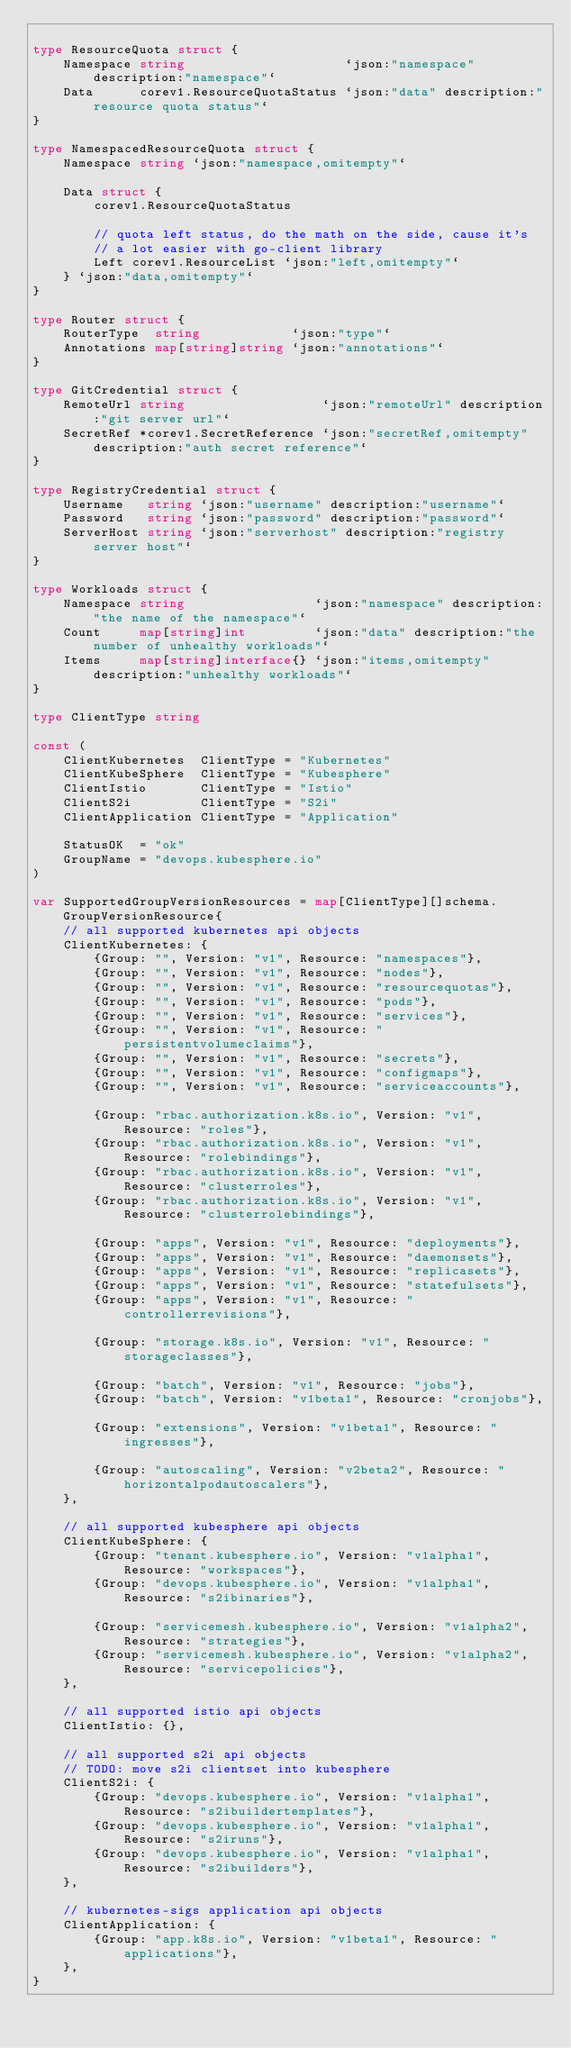<code> <loc_0><loc_0><loc_500><loc_500><_Go_>
type ResourceQuota struct {
	Namespace string                     `json:"namespace" description:"namespace"`
	Data      corev1.ResourceQuotaStatus `json:"data" description:"resource quota status"`
}

type NamespacedResourceQuota struct {
	Namespace string `json:"namespace,omitempty"`

	Data struct {
		corev1.ResourceQuotaStatus

		// quota left status, do the math on the side, cause it's
		// a lot easier with go-client library
		Left corev1.ResourceList `json:"left,omitempty"`
	} `json:"data,omitempty"`
}

type Router struct {
	RouterType  string            `json:"type"`
	Annotations map[string]string `json:"annotations"`
}

type GitCredential struct {
	RemoteUrl string                  `json:"remoteUrl" description:"git server url"`
	SecretRef *corev1.SecretReference `json:"secretRef,omitempty" description:"auth secret reference"`
}

type RegistryCredential struct {
	Username   string `json:"username" description:"username"`
	Password   string `json:"password" description:"password"`
	ServerHost string `json:"serverhost" description:"registry server host"`
}

type Workloads struct {
	Namespace string                 `json:"namespace" description:"the name of the namespace"`
	Count     map[string]int         `json:"data" description:"the number of unhealthy workloads"`
	Items     map[string]interface{} `json:"items,omitempty" description:"unhealthy workloads"`
}

type ClientType string

const (
	ClientKubernetes  ClientType = "Kubernetes"
	ClientKubeSphere  ClientType = "Kubesphere"
	ClientIstio       ClientType = "Istio"
	ClientS2i         ClientType = "S2i"
	ClientApplication ClientType = "Application"

	StatusOK  = "ok"
	GroupName = "devops.kubesphere.io"
)

var SupportedGroupVersionResources = map[ClientType][]schema.GroupVersionResource{
	// all supported kubernetes api objects
	ClientKubernetes: {
		{Group: "", Version: "v1", Resource: "namespaces"},
		{Group: "", Version: "v1", Resource: "nodes"},
		{Group: "", Version: "v1", Resource: "resourcequotas"},
		{Group: "", Version: "v1", Resource: "pods"},
		{Group: "", Version: "v1", Resource: "services"},
		{Group: "", Version: "v1", Resource: "persistentvolumeclaims"},
		{Group: "", Version: "v1", Resource: "secrets"},
		{Group: "", Version: "v1", Resource: "configmaps"},
		{Group: "", Version: "v1", Resource: "serviceaccounts"},

		{Group: "rbac.authorization.k8s.io", Version: "v1", Resource: "roles"},
		{Group: "rbac.authorization.k8s.io", Version: "v1", Resource: "rolebindings"},
		{Group: "rbac.authorization.k8s.io", Version: "v1", Resource: "clusterroles"},
		{Group: "rbac.authorization.k8s.io", Version: "v1", Resource: "clusterrolebindings"},

		{Group: "apps", Version: "v1", Resource: "deployments"},
		{Group: "apps", Version: "v1", Resource: "daemonsets"},
		{Group: "apps", Version: "v1", Resource: "replicasets"},
		{Group: "apps", Version: "v1", Resource: "statefulsets"},
		{Group: "apps", Version: "v1", Resource: "controllerrevisions"},

		{Group: "storage.k8s.io", Version: "v1", Resource: "storageclasses"},

		{Group: "batch", Version: "v1", Resource: "jobs"},
		{Group: "batch", Version: "v1beta1", Resource: "cronjobs"},

		{Group: "extensions", Version: "v1beta1", Resource: "ingresses"},

		{Group: "autoscaling", Version: "v2beta2", Resource: "horizontalpodautoscalers"},
	},

	// all supported kubesphere api objects
	ClientKubeSphere: {
		{Group: "tenant.kubesphere.io", Version: "v1alpha1", Resource: "workspaces"},
		{Group: "devops.kubesphere.io", Version: "v1alpha1", Resource: "s2ibinaries"},

		{Group: "servicemesh.kubesphere.io", Version: "v1alpha2", Resource: "strategies"},
		{Group: "servicemesh.kubesphere.io", Version: "v1alpha2", Resource: "servicepolicies"},
	},

	// all supported istio api objects
	ClientIstio: {},

	// all supported s2i api objects
	// TODO: move s2i clientset into kubesphere
	ClientS2i: {
		{Group: "devops.kubesphere.io", Version: "v1alpha1", Resource: "s2ibuildertemplates"},
		{Group: "devops.kubesphere.io", Version: "v1alpha1", Resource: "s2iruns"},
		{Group: "devops.kubesphere.io", Version: "v1alpha1", Resource: "s2ibuilders"},
	},

	// kubernetes-sigs application api objects
	ClientApplication: {
		{Group: "app.k8s.io", Version: "v1beta1", Resource: "applications"},
	},
}
</code> 